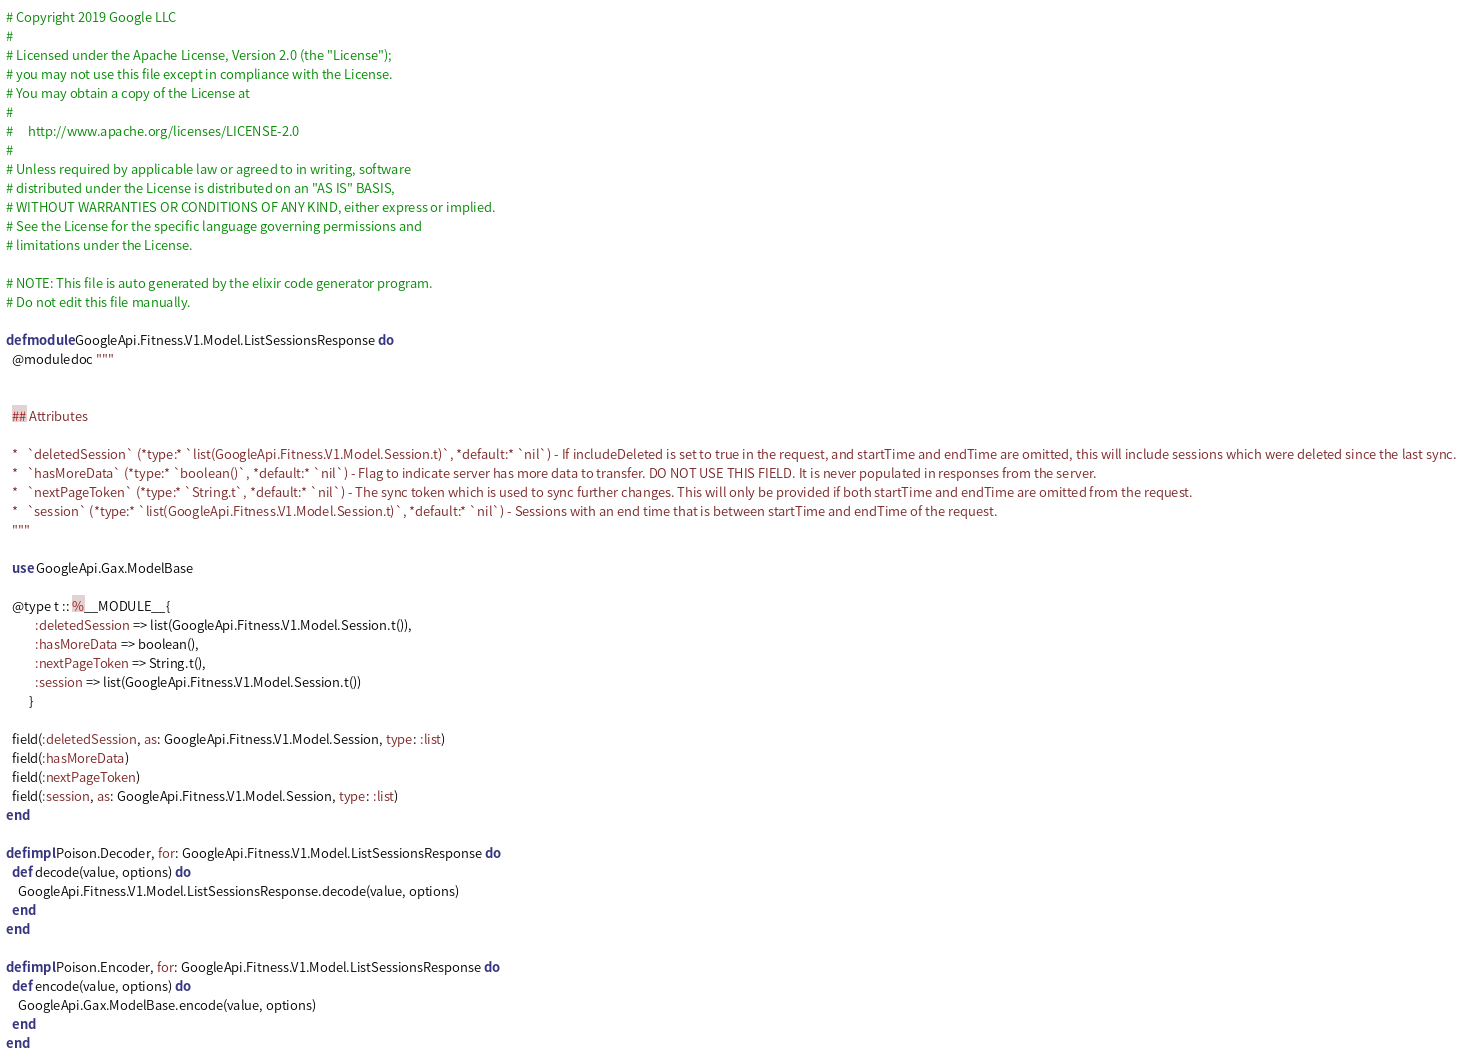<code> <loc_0><loc_0><loc_500><loc_500><_Elixir_># Copyright 2019 Google LLC
#
# Licensed under the Apache License, Version 2.0 (the "License");
# you may not use this file except in compliance with the License.
# You may obtain a copy of the License at
#
#     http://www.apache.org/licenses/LICENSE-2.0
#
# Unless required by applicable law or agreed to in writing, software
# distributed under the License is distributed on an "AS IS" BASIS,
# WITHOUT WARRANTIES OR CONDITIONS OF ANY KIND, either express or implied.
# See the License for the specific language governing permissions and
# limitations under the License.

# NOTE: This file is auto generated by the elixir code generator program.
# Do not edit this file manually.

defmodule GoogleApi.Fitness.V1.Model.ListSessionsResponse do
  @moduledoc """


  ## Attributes

  *   `deletedSession` (*type:* `list(GoogleApi.Fitness.V1.Model.Session.t)`, *default:* `nil`) - If includeDeleted is set to true in the request, and startTime and endTime are omitted, this will include sessions which were deleted since the last sync.
  *   `hasMoreData` (*type:* `boolean()`, *default:* `nil`) - Flag to indicate server has more data to transfer. DO NOT USE THIS FIELD. It is never populated in responses from the server.
  *   `nextPageToken` (*type:* `String.t`, *default:* `nil`) - The sync token which is used to sync further changes. This will only be provided if both startTime and endTime are omitted from the request.
  *   `session` (*type:* `list(GoogleApi.Fitness.V1.Model.Session.t)`, *default:* `nil`) - Sessions with an end time that is between startTime and endTime of the request.
  """

  use GoogleApi.Gax.ModelBase

  @type t :: %__MODULE__{
          :deletedSession => list(GoogleApi.Fitness.V1.Model.Session.t()),
          :hasMoreData => boolean(),
          :nextPageToken => String.t(),
          :session => list(GoogleApi.Fitness.V1.Model.Session.t())
        }

  field(:deletedSession, as: GoogleApi.Fitness.V1.Model.Session, type: :list)
  field(:hasMoreData)
  field(:nextPageToken)
  field(:session, as: GoogleApi.Fitness.V1.Model.Session, type: :list)
end

defimpl Poison.Decoder, for: GoogleApi.Fitness.V1.Model.ListSessionsResponse do
  def decode(value, options) do
    GoogleApi.Fitness.V1.Model.ListSessionsResponse.decode(value, options)
  end
end

defimpl Poison.Encoder, for: GoogleApi.Fitness.V1.Model.ListSessionsResponse do
  def encode(value, options) do
    GoogleApi.Gax.ModelBase.encode(value, options)
  end
end
</code> 